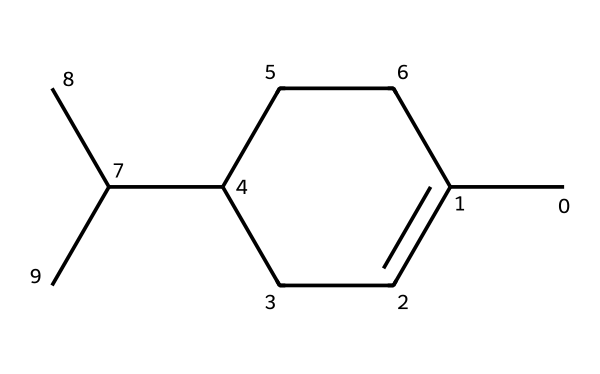What is the total number of carbon atoms in this structure? Count the carbon atoms represented in the structural formula. The structure shows a total of six carbon chains, with additional branches. Counting all of them gives a total of twelve carbon atoms.
Answer: twelve How many double bonds are present in the structure? Examine the chemical structure to identify the presence of double bonds. The structure does not depict any double bonds, confirming there are zero double bonds in the molecule.
Answer: zero What functional group is prominent in this essential oil? Analyze the structure for identifiable functional groups. The analysis shows it contains a branched structure with alcohol functionalities, characteristic of essential oil compositions.
Answer: alcohol Is this compound a cyclic or acyclic compound? Look at the overall arrangement of the atoms within the structure. The presence of a ring structure indicates that this compound is cyclic.
Answer: cyclic What type of bonding is primarily responsible for the stability of this compound? Assess the types of bonds present in the molecular structure, focusing on carbon-carbon or carbon-hydrogen bonds. The predominant type of bonding in this compound is single covalent bonds, contributing to its stability.
Answer: single covalent bonds What is one key characteristic that relates juniper berry oil to its use in gin production? Analyze the compound structure to identify the traits relevant to flavor and aroma. The presence of terpenes in the oil is significant for imparting distinctive flavors to gin, indicating its essential role in gin production.
Answer: terpenes 